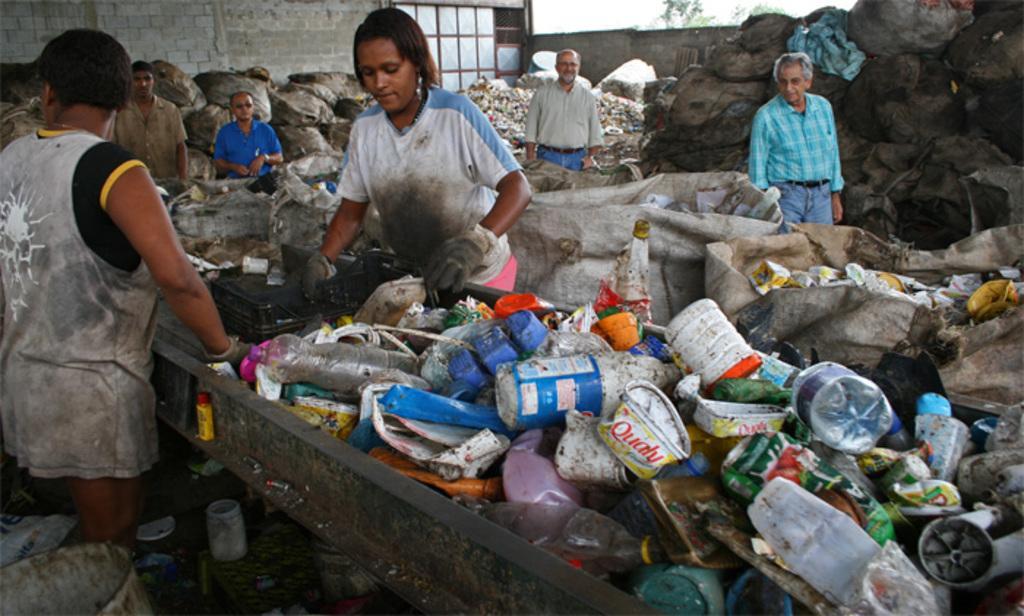In one or two sentences, can you explain what this image depicts? In this image I can see the garbage materials and also there are few people standing. In the background there is a wall and some trees. 